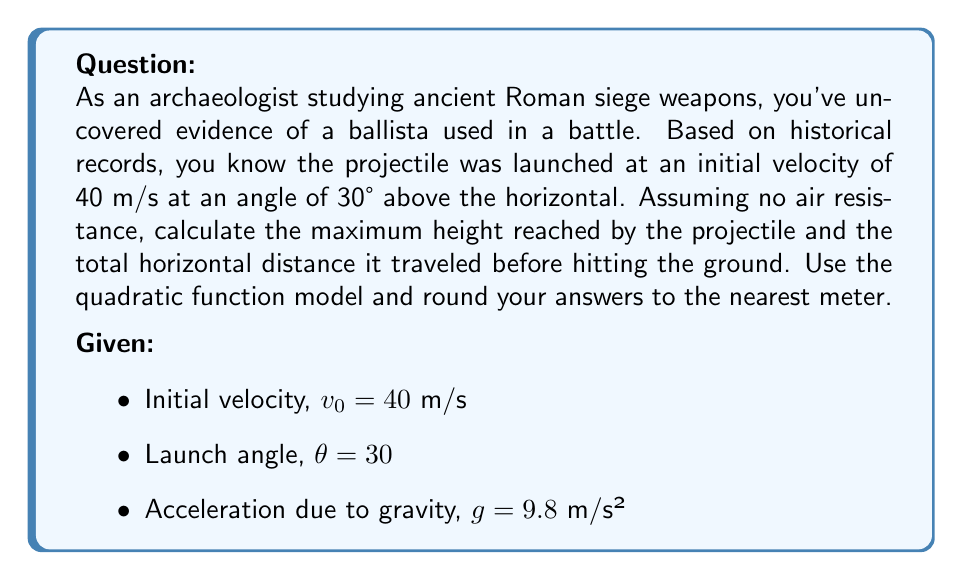Help me with this question. To solve this problem, we'll use the quadratic function model for projectile motion. Let's break it down step by step:

1. Decompose the initial velocity into horizontal and vertical components:
   $v_{0x} = v_0 \cos(\theta) = 40 \cos(30°) = 34.64$ m/s
   $v_{0y} = v_0 \sin(\theta) = 40 \sin(30°) = 20$ m/s

2. The quadratic function for the projectile's height (y) in terms of time (t) is:
   $y(t) = -\frac{1}{2}gt^2 + v_{0y}t$

3. To find the maximum height, we need to find when the vertical velocity is zero:
   $v_y(t) = -gt + v_{0y} = 0$
   $t_{max} = \frac{v_{0y}}{g} = \frac{20}{9.8} = 2.04$ seconds

4. Substitute this time into the height function to find the maximum height:
   $y_{max} = -\frac{1}{2}g(2.04)^2 + v_{0y}(2.04)$
   $y_{max} = -\frac{1}{2}(9.8)(2.04)^2 + 20(2.04) = 20.41$ meters

5. For the total horizontal distance, we need the time when the projectile hits the ground. We can find this by setting y(t) = 0:
   $0 = -\frac{1}{2}gt^2 + v_{0y}t$
   $t = 0$ or $t = \frac{2v_{0y}}{g} = \frac{2(20)}{9.8} = 4.08$ seconds

6. The horizontal distance is given by $x = v_{0x}t$:
   $x = 34.64 * 4.08 = 141.33$ meters

Rounding to the nearest meter:
Maximum height: 20 meters
Total horizontal distance: 141 meters
Answer: Maximum height: 20 meters
Total horizontal distance: 141 meters 